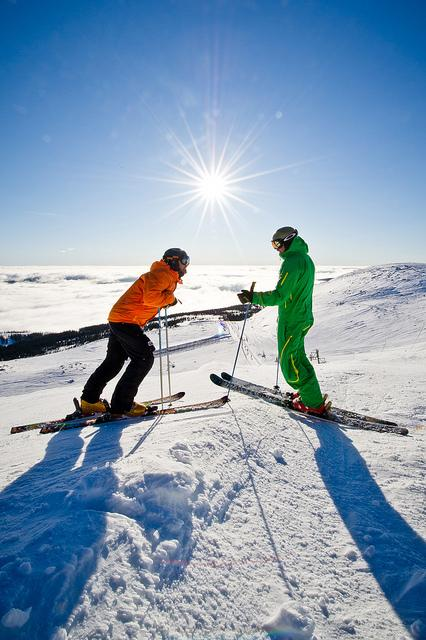What part of the world are the skiers most likely in? Please explain your reasoning. colorado. The state is known for skiing and other winter sports due to how much it snows. 